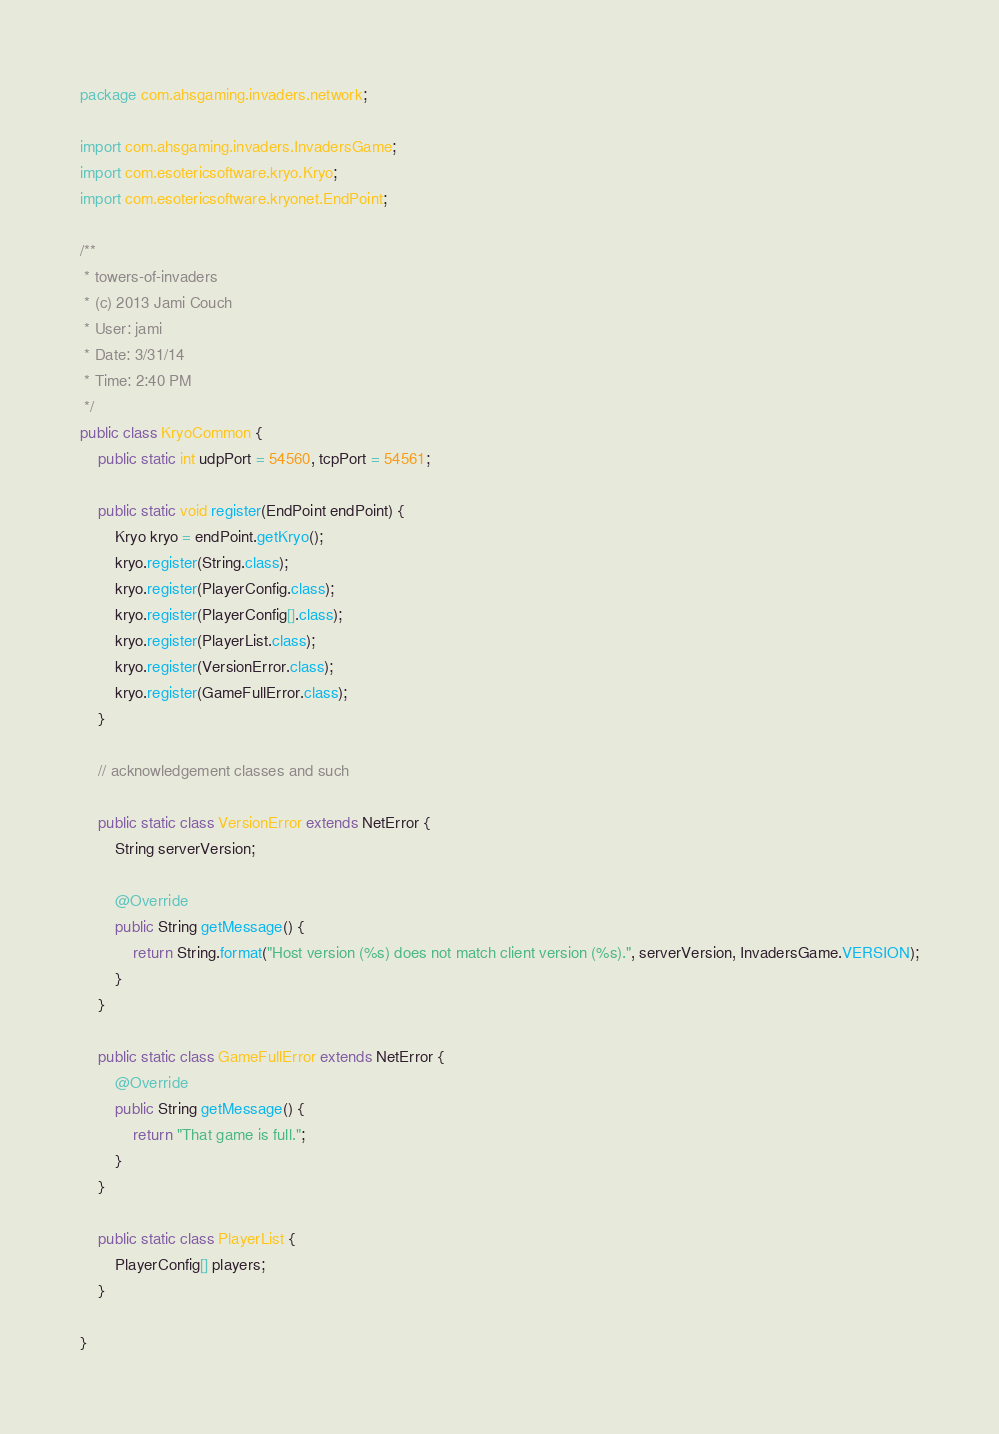Convert code to text. <code><loc_0><loc_0><loc_500><loc_500><_Java_>package com.ahsgaming.invaders.network;

import com.ahsgaming.invaders.InvadersGame;
import com.esotericsoftware.kryo.Kryo;
import com.esotericsoftware.kryonet.EndPoint;

/**
 * towers-of-invaders
 * (c) 2013 Jami Couch
 * User: jami
 * Date: 3/31/14
 * Time: 2:40 PM
 */
public class KryoCommon {
    public static int udpPort = 54560, tcpPort = 54561;

    public static void register(EndPoint endPoint) {
        Kryo kryo = endPoint.getKryo();
        kryo.register(String.class);
        kryo.register(PlayerConfig.class);
        kryo.register(PlayerConfig[].class);
        kryo.register(PlayerList.class);
        kryo.register(VersionError.class);
        kryo.register(GameFullError.class);
    }

    // acknowledgement classes and such

    public static class VersionError extends NetError {
        String serverVersion;

        @Override
        public String getMessage() {
            return String.format("Host version (%s) does not match client version (%s).", serverVersion, InvadersGame.VERSION);
        }
    }

    public static class GameFullError extends NetError {
        @Override
        public String getMessage() {
            return "That game is full.";
        }
    }

    public static class PlayerList {
        PlayerConfig[] players;
    }

}
</code> 